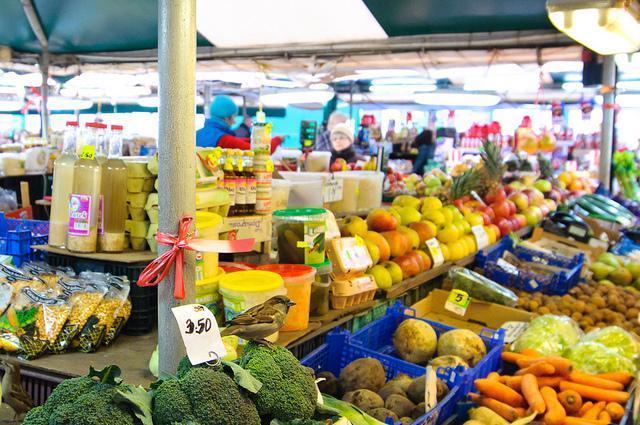How many broccolis can be seen?
Give a very brief answer. 3. How many bottles are there?
Give a very brief answer. 3. 